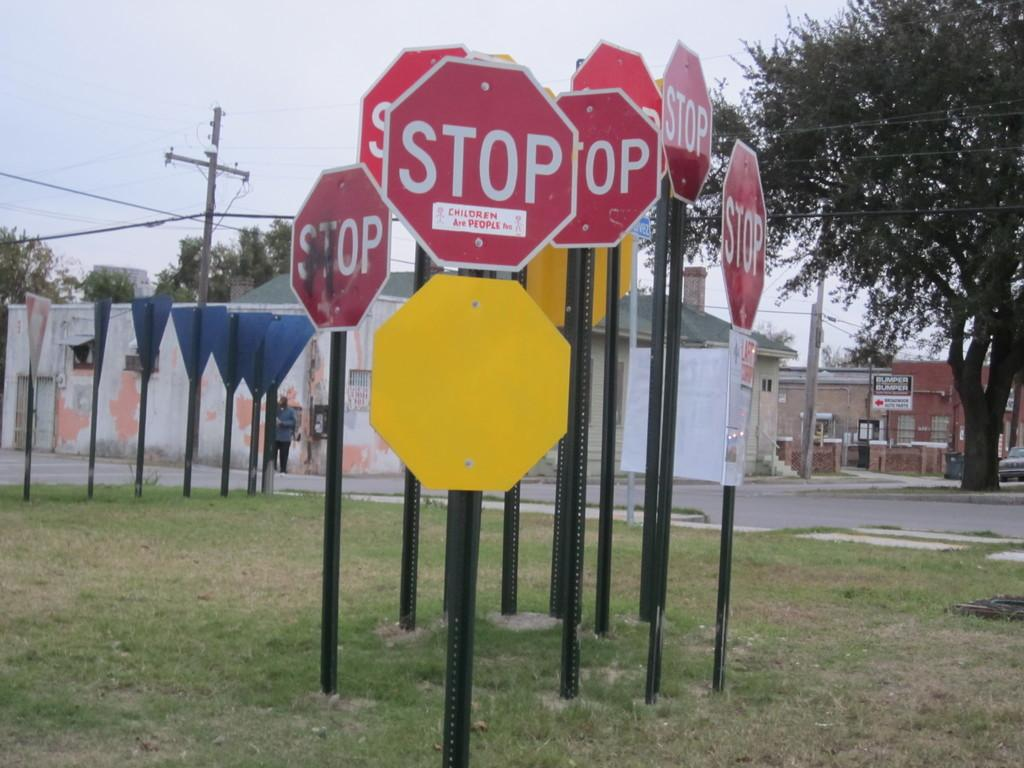<image>
Present a compact description of the photo's key features. several stop signs are grouped together in a small area of grass and one says that children are people too. 